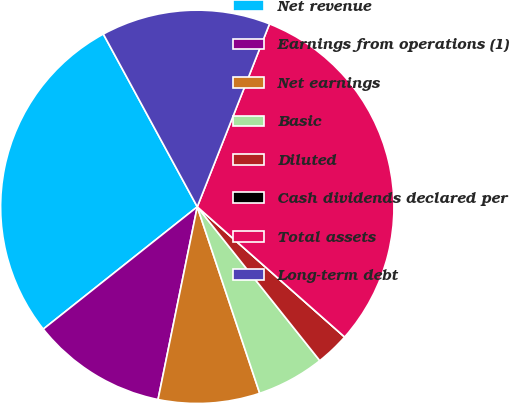<chart> <loc_0><loc_0><loc_500><loc_500><pie_chart><fcel>Net revenue<fcel>Earnings from operations (1)<fcel>Net earnings<fcel>Basic<fcel>Diluted<fcel>Cash dividends declared per<fcel>Total assets<fcel>Long-term debt<nl><fcel>27.75%<fcel>11.12%<fcel>8.34%<fcel>5.56%<fcel>2.78%<fcel>0.0%<fcel>30.53%<fcel>13.91%<nl></chart> 